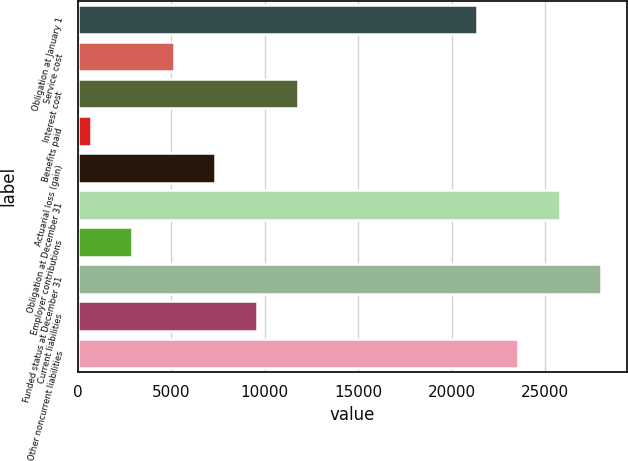Convert chart to OTSL. <chart><loc_0><loc_0><loc_500><loc_500><bar_chart><fcel>Obligation at January 1<fcel>Service cost<fcel>Interest cost<fcel>Benefits paid<fcel>Actuarial loss (gain)<fcel>Obligation at December 31<fcel>Employer contributions<fcel>Funded status at December 31<fcel>Current liabilities<fcel>Other noncurrent liabilities<nl><fcel>21354<fcel>5123.8<fcel>11773<fcel>691<fcel>7340.2<fcel>25786.8<fcel>2907.4<fcel>28003.2<fcel>9556.6<fcel>23570.4<nl></chart> 